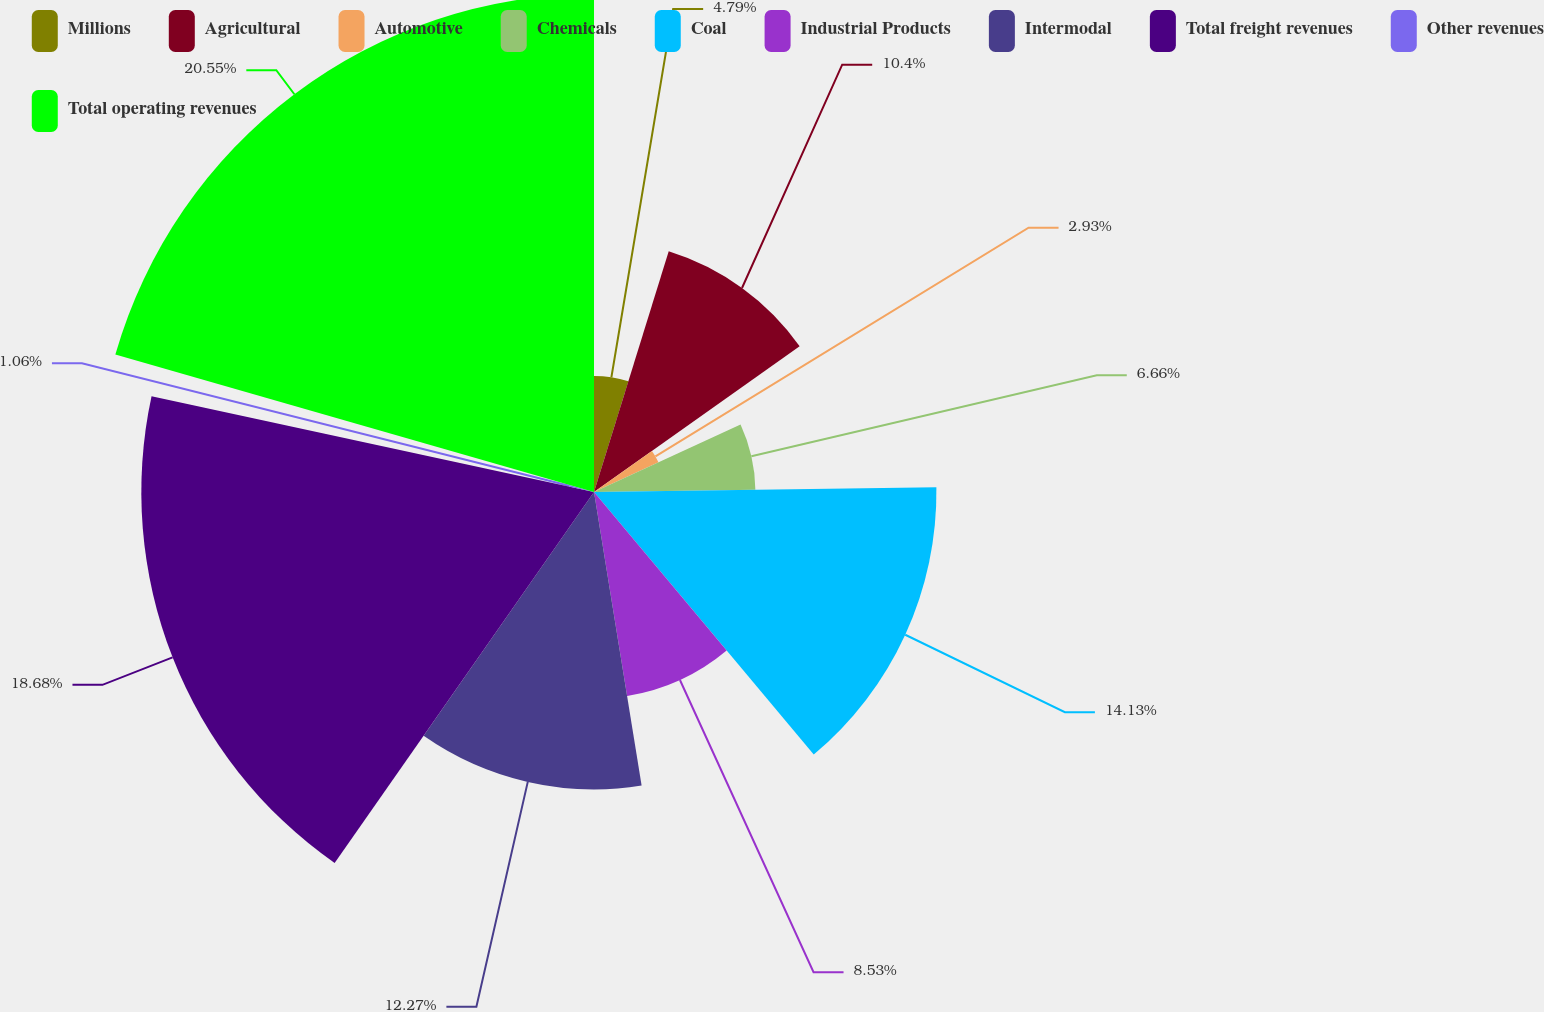<chart> <loc_0><loc_0><loc_500><loc_500><pie_chart><fcel>Millions<fcel>Agricultural<fcel>Automotive<fcel>Chemicals<fcel>Coal<fcel>Industrial Products<fcel>Intermodal<fcel>Total freight revenues<fcel>Other revenues<fcel>Total operating revenues<nl><fcel>4.79%<fcel>10.4%<fcel>2.93%<fcel>6.66%<fcel>14.13%<fcel>8.53%<fcel>12.27%<fcel>18.68%<fcel>1.06%<fcel>20.55%<nl></chart> 